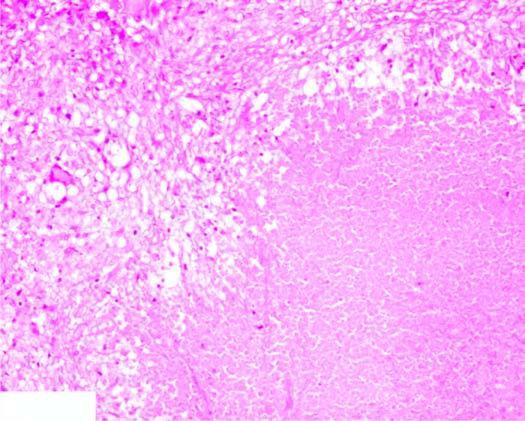what is there?
Answer the question using a single word or phrase. Eosinophilic 